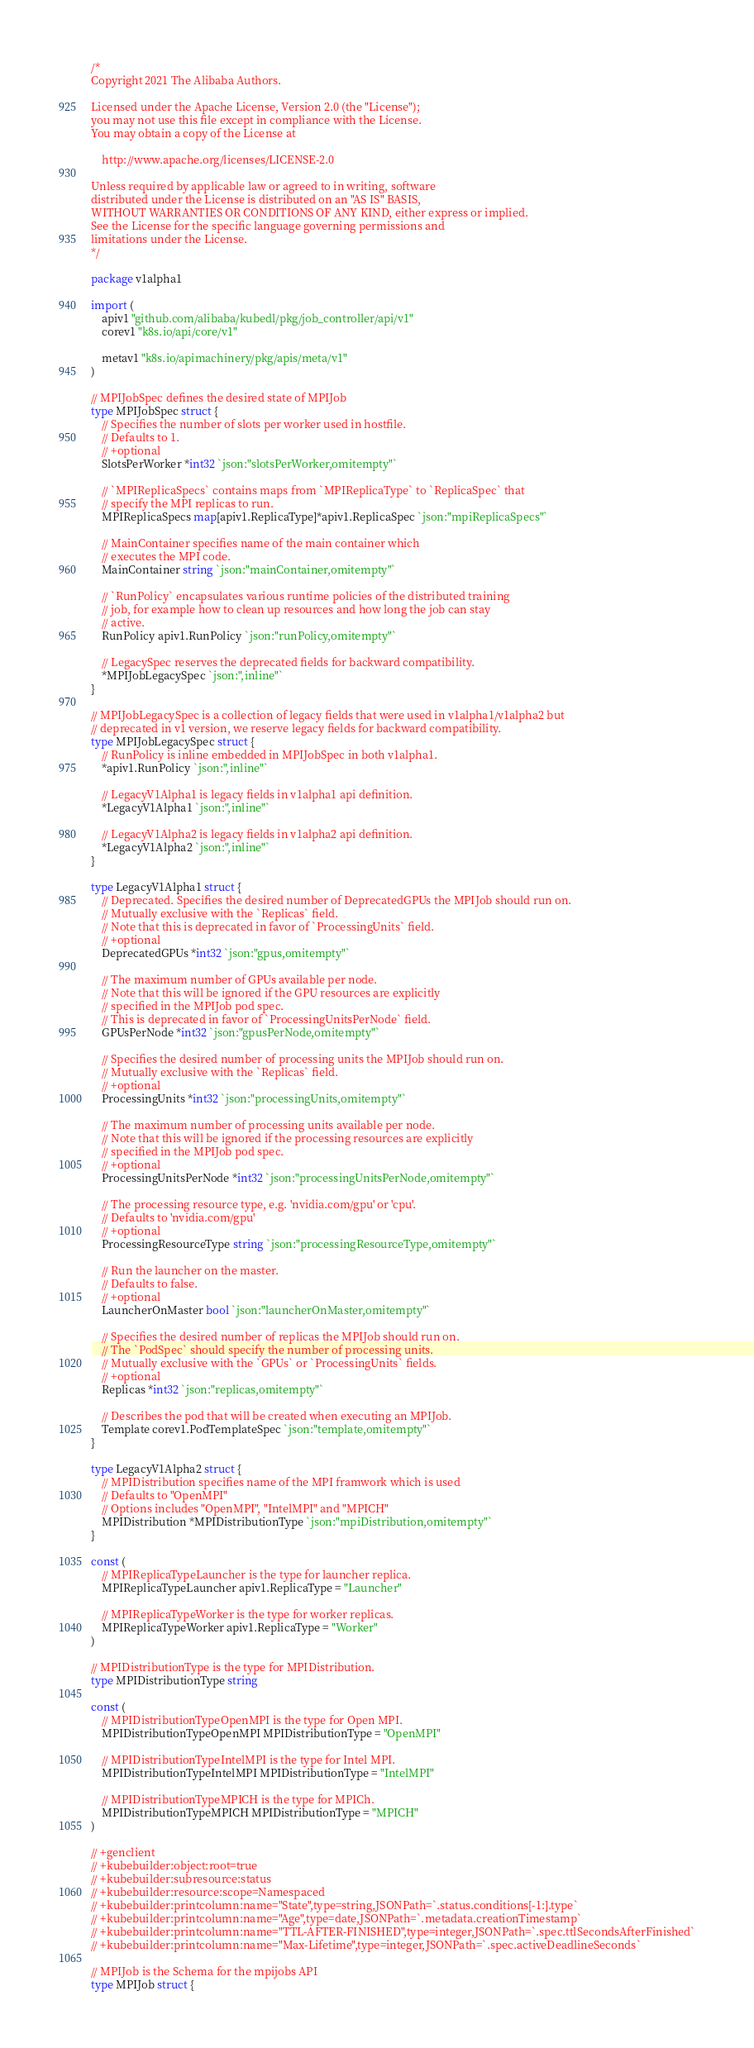Convert code to text. <code><loc_0><loc_0><loc_500><loc_500><_Go_>/*
Copyright 2021 The Alibaba Authors.

Licensed under the Apache License, Version 2.0 (the "License");
you may not use this file except in compliance with the License.
You may obtain a copy of the License at

    http://www.apache.org/licenses/LICENSE-2.0

Unless required by applicable law or agreed to in writing, software
distributed under the License is distributed on an "AS IS" BASIS,
WITHOUT WARRANTIES OR CONDITIONS OF ANY KIND, either express or implied.
See the License for the specific language governing permissions and
limitations under the License.
*/

package v1alpha1

import (
	apiv1 "github.com/alibaba/kubedl/pkg/job_controller/api/v1"
	corev1 "k8s.io/api/core/v1"

	metav1 "k8s.io/apimachinery/pkg/apis/meta/v1"
)

// MPIJobSpec defines the desired state of MPIJob
type MPIJobSpec struct {
	// Specifies the number of slots per worker used in hostfile.
	// Defaults to 1.
	// +optional
	SlotsPerWorker *int32 `json:"slotsPerWorker,omitempty"`

	// `MPIReplicaSpecs` contains maps from `MPIReplicaType` to `ReplicaSpec` that
	// specify the MPI replicas to run.
	MPIReplicaSpecs map[apiv1.ReplicaType]*apiv1.ReplicaSpec `json:"mpiReplicaSpecs"`

	// MainContainer specifies name of the main container which
	// executes the MPI code.
	MainContainer string `json:"mainContainer,omitempty"`

	// `RunPolicy` encapsulates various runtime policies of the distributed training
	// job, for example how to clean up resources and how long the job can stay
	// active.
	RunPolicy apiv1.RunPolicy `json:"runPolicy,omitempty"`

	// LegacySpec reserves the deprecated fields for backward compatibility.
	*MPIJobLegacySpec `json:",inline"`
}

// MPIJobLegacySpec is a collection of legacy fields that were used in v1alpha1/v1alpha2 but
// deprecated in v1 version, we reserve legacy fields for backward compatibility.
type MPIJobLegacySpec struct {
	// RunPolicy is inline embedded in MPIJobSpec in both v1alpha1.
	*apiv1.RunPolicy `json:",inline"`

	// LegacyV1Alpha1 is legacy fields in v1alpha1 api definition.
	*LegacyV1Alpha1 `json:",inline"`

	// LegacyV1Alpha2 is legacy fields in v1alpha2 api definition.
	*LegacyV1Alpha2 `json:",inline"`
}

type LegacyV1Alpha1 struct {
	// Deprecated. Specifies the desired number of DeprecatedGPUs the MPIJob should run on.
	// Mutually exclusive with the `Replicas` field.
	// Note that this is deprecated in favor of `ProcessingUnits` field.
	// +optional
	DeprecatedGPUs *int32 `json:"gpus,omitempty"`

	// The maximum number of GPUs available per node.
	// Note that this will be ignored if the GPU resources are explicitly
	// specified in the MPIJob pod spec.
	// This is deprecated in favor of `ProcessingUnitsPerNode` field.
	GPUsPerNode *int32 `json:"gpusPerNode,omitempty"`

	// Specifies the desired number of processing units the MPIJob should run on.
	// Mutually exclusive with the `Replicas` field.
	// +optional
	ProcessingUnits *int32 `json:"processingUnits,omitempty"`

	// The maximum number of processing units available per node.
	// Note that this will be ignored if the processing resources are explicitly
	// specified in the MPIJob pod spec.
	// +optional
	ProcessingUnitsPerNode *int32 `json:"processingUnitsPerNode,omitempty"`

	// The processing resource type, e.g. 'nvidia.com/gpu' or 'cpu'.
	// Defaults to 'nvidia.com/gpu'
	// +optional
	ProcessingResourceType string `json:"processingResourceType,omitempty"`

	// Run the launcher on the master.
	// Defaults to false.
	// +optional
	LauncherOnMaster bool `json:"launcherOnMaster,omitempty"`

	// Specifies the desired number of replicas the MPIJob should run on.
	// The `PodSpec` should specify the number of processing units.
	// Mutually exclusive with the `GPUs` or `ProcessingUnits` fields.
	// +optional
	Replicas *int32 `json:"replicas,omitempty"`

	// Describes the pod that will be created when executing an MPIJob.
	Template corev1.PodTemplateSpec `json:"template,omitempty"`
}

type LegacyV1Alpha2 struct {
	// MPIDistribution specifies name of the MPI framwork which is used
	// Defaults to "OpenMPI"
	// Options includes "OpenMPI", "IntelMPI" and "MPICH"
	MPIDistribution *MPIDistributionType `json:"mpiDistribution,omitempty"`
}

const (
	// MPIReplicaTypeLauncher is the type for launcher replica.
	MPIReplicaTypeLauncher apiv1.ReplicaType = "Launcher"

	// MPIReplicaTypeWorker is the type for worker replicas.
	MPIReplicaTypeWorker apiv1.ReplicaType = "Worker"
)

// MPIDistributionType is the type for MPIDistribution.
type MPIDistributionType string

const (
	// MPIDistributionTypeOpenMPI is the type for Open MPI.
	MPIDistributionTypeOpenMPI MPIDistributionType = "OpenMPI"

	// MPIDistributionTypeIntelMPI is the type for Intel MPI.
	MPIDistributionTypeIntelMPI MPIDistributionType = "IntelMPI"

	// MPIDistributionTypeMPICH is the type for MPICh.
	MPIDistributionTypeMPICH MPIDistributionType = "MPICH"
)

// +genclient
// +kubebuilder:object:root=true
// +kubebuilder:subresource:status
// +kubebuilder:resource:scope=Namespaced
// +kubebuilder:printcolumn:name="State",type=string,JSONPath=`.status.conditions[-1:].type`
// +kubebuilder:printcolumn:name="Age",type=date,JSONPath=`.metadata.creationTimestamp`
// +kubebuilder:printcolumn:name="TTL-AFTER-FINISHED",type=integer,JSONPath=`.spec.ttlSecondsAfterFinished`
// +kubebuilder:printcolumn:name="Max-Lifetime",type=integer,JSONPath=`.spec.activeDeadlineSeconds`

// MPIJob is the Schema for the mpijobs API
type MPIJob struct {</code> 